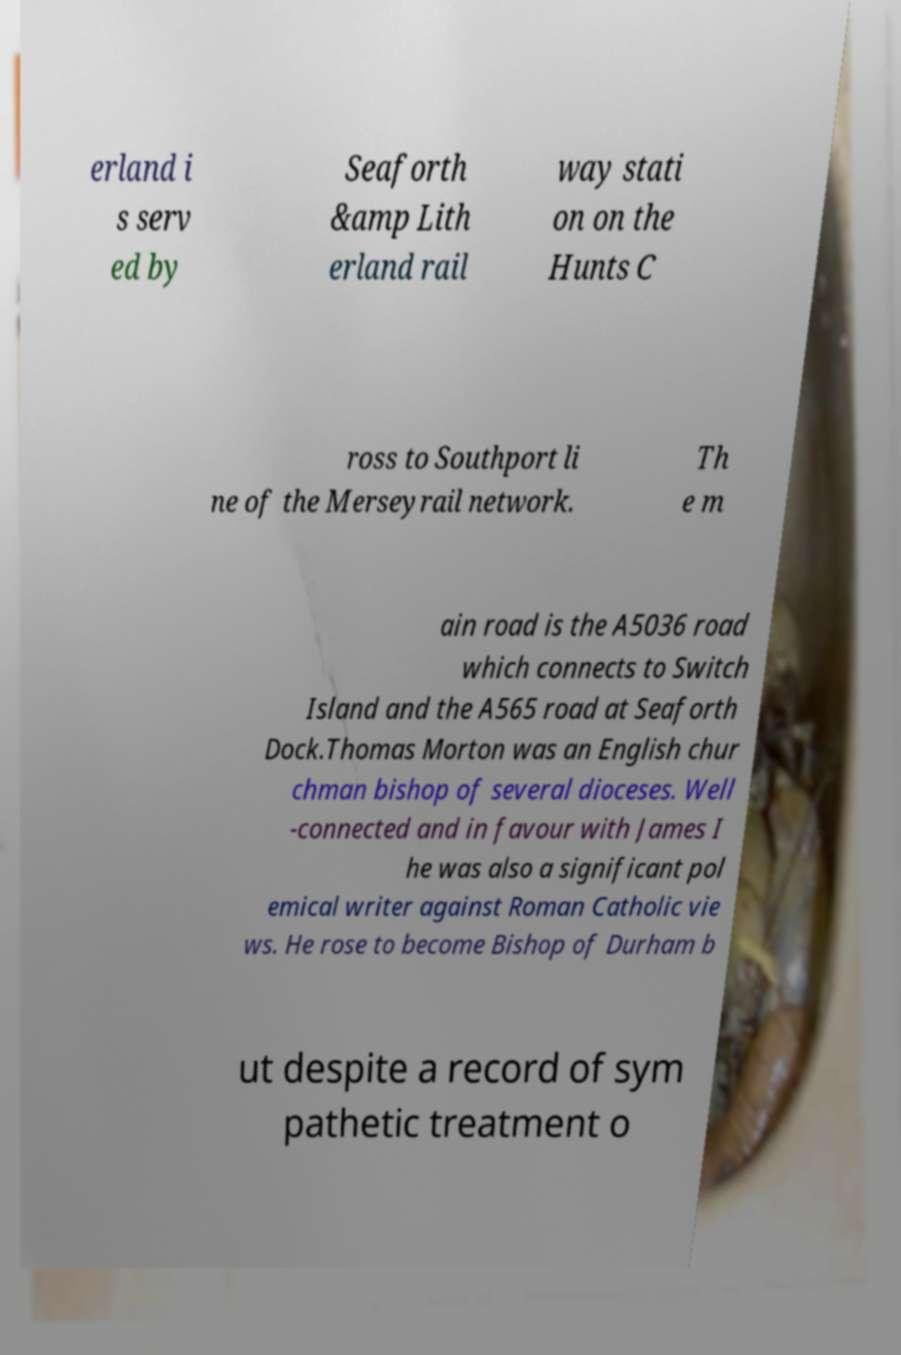Please identify and transcribe the text found in this image. erland i s serv ed by Seaforth &amp Lith erland rail way stati on on the Hunts C ross to Southport li ne of the Merseyrail network. Th e m ain road is the A5036 road which connects to Switch Island and the A565 road at Seaforth Dock.Thomas Morton was an English chur chman bishop of several dioceses. Well -connected and in favour with James I he was also a significant pol emical writer against Roman Catholic vie ws. He rose to become Bishop of Durham b ut despite a record of sym pathetic treatment o 